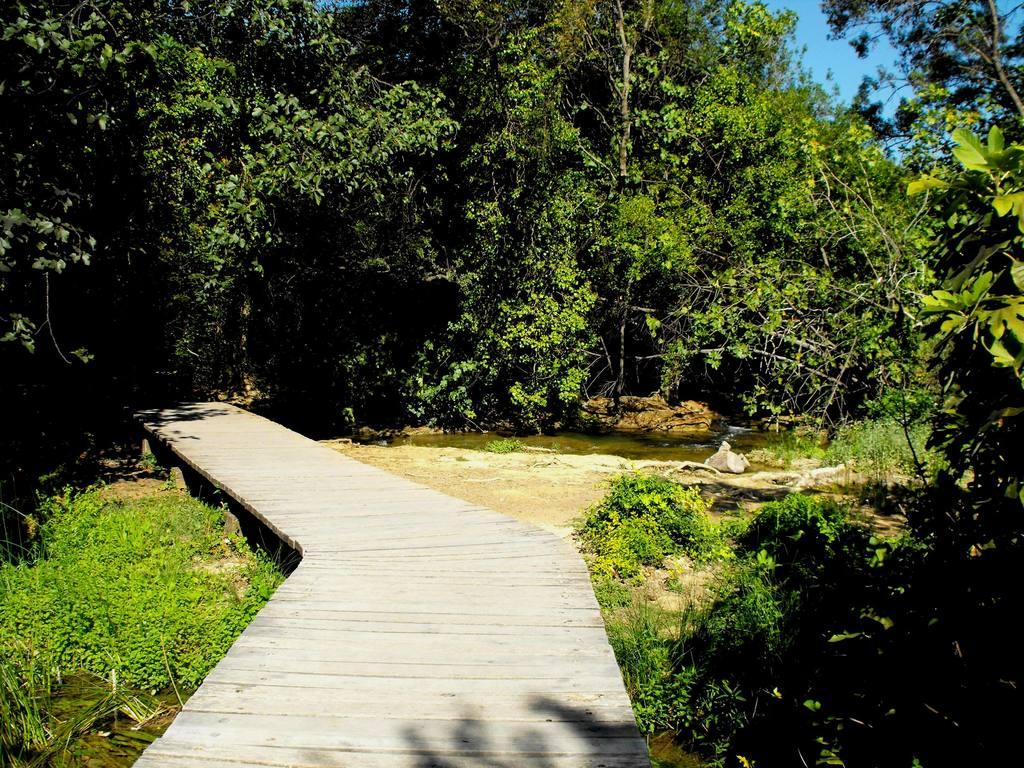What type of path is visible in the image? There is a wooden path in the image. What is the wooden path situated on? The wooden path is on plants. What else can be seen in the image besides the wooden path? There is water visible in the image. What is visible in the background of the image? The background of the image includes plants. What is visible at the top of the image? The sky is visible at the top of the image. What type of rule is being enforced by the plants in the image? There is no rule being enforced by the plants in the image; they are simply part of the natural environment. What type of growth can be seen on the wooden path in the image? There is no growth visible on the wooden path in the image; it is a solid structure. 